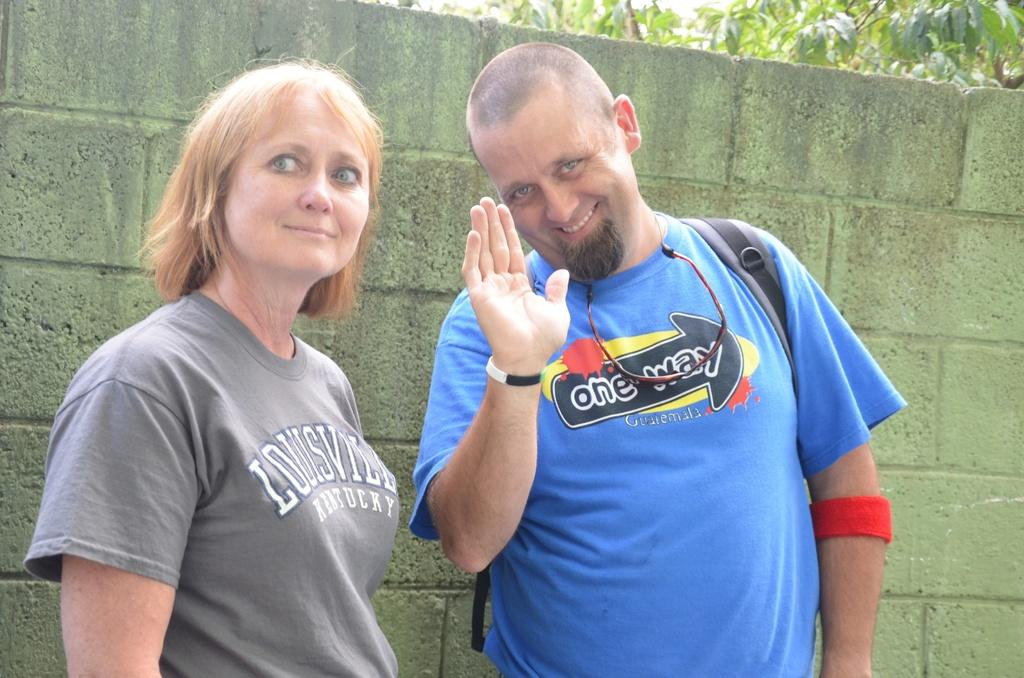What is the gender of the person on the right side of the image? There is a man on the right side of the image. What is the gender of the person on the left side of the image? There is a woman on the left side of the image. What is the man doing with his hand in the image? The man is raising his hand. What can be seen in the background of the image? There is a wall in the background of the image, and behind the wall, there is a tree. What type of crime is being committed by the deer in the image? There is no deer present in the image, and therefore no crime can be committed by a deer. 